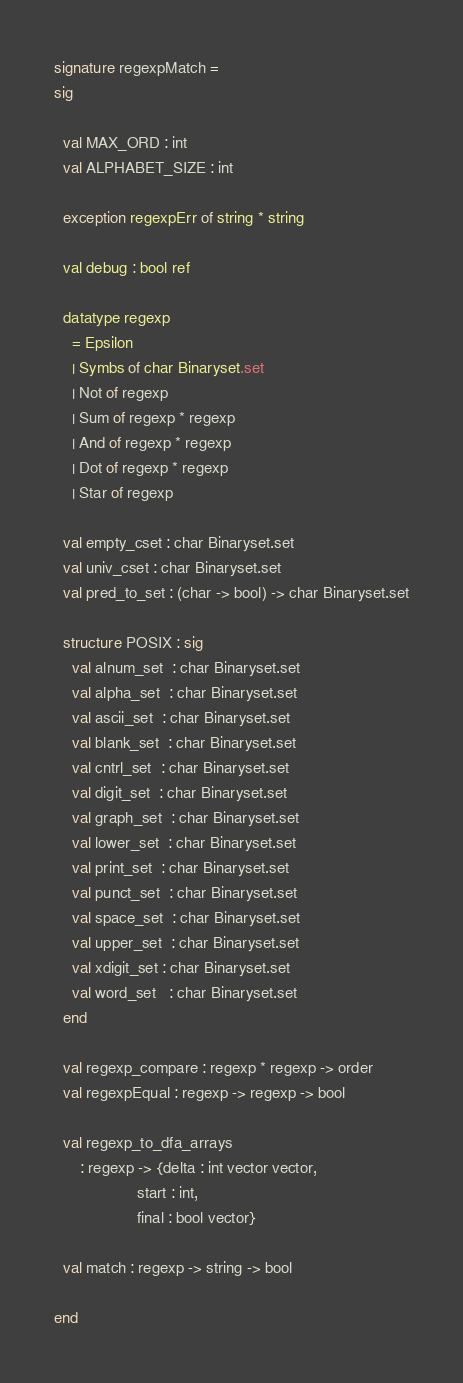<code> <loc_0><loc_0><loc_500><loc_500><_SML_>signature regexpMatch =
sig

  val MAX_ORD : int
  val ALPHABET_SIZE : int

  exception regexpErr of string * string

  val debug : bool ref

  datatype regexp
    = Epsilon
    | Symbs of char Binaryset.set
    | Not of regexp
    | Sum of regexp * regexp
    | And of regexp * regexp
    | Dot of regexp * regexp
    | Star of regexp

  val empty_cset : char Binaryset.set
  val univ_cset : char Binaryset.set
  val pred_to_set : (char -> bool) -> char Binaryset.set

  structure POSIX : sig
    val alnum_set  : char Binaryset.set
    val alpha_set  : char Binaryset.set
    val ascii_set  : char Binaryset.set
    val blank_set  : char Binaryset.set
    val cntrl_set  : char Binaryset.set
    val digit_set  : char Binaryset.set
    val graph_set  : char Binaryset.set
    val lower_set  : char Binaryset.set
    val print_set  : char Binaryset.set
    val punct_set  : char Binaryset.set
    val space_set  : char Binaryset.set
    val upper_set  : char Binaryset.set
    val xdigit_set : char Binaryset.set
    val word_set   : char Binaryset.set
  end

  val regexp_compare : regexp * regexp -> order
  val regexpEqual : regexp -> regexp -> bool

  val regexp_to_dfa_arrays
      : regexp -> {delta : int vector vector,
                   start : int,
                   final : bool vector}

  val match : regexp -> string -> bool

end
</code> 